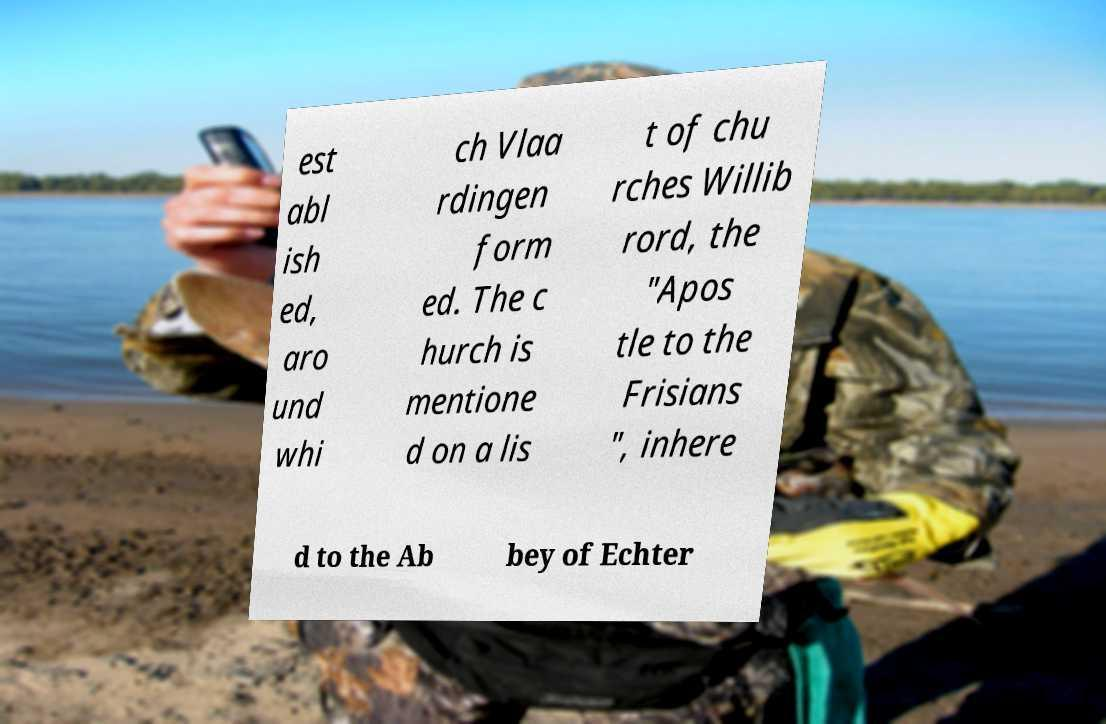Can you read and provide the text displayed in the image?This photo seems to have some interesting text. Can you extract and type it out for me? est abl ish ed, aro und whi ch Vlaa rdingen form ed. The c hurch is mentione d on a lis t of chu rches Willib rord, the "Apos tle to the Frisians ", inhere d to the Ab bey of Echter 